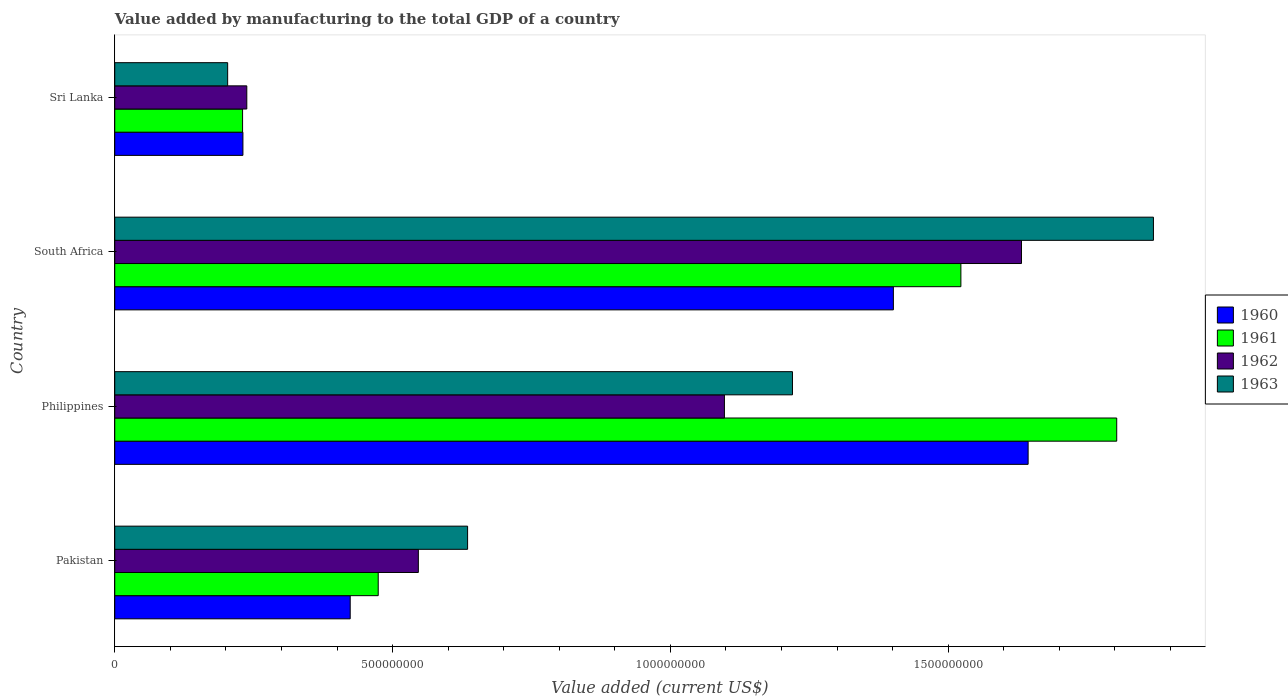How many groups of bars are there?
Your response must be concise. 4. Are the number of bars on each tick of the Y-axis equal?
Make the answer very short. Yes. How many bars are there on the 1st tick from the bottom?
Make the answer very short. 4. What is the label of the 3rd group of bars from the top?
Offer a terse response. Philippines. What is the value added by manufacturing to the total GDP in 1960 in Philippines?
Ensure brevity in your answer.  1.64e+09. Across all countries, what is the maximum value added by manufacturing to the total GDP in 1961?
Your answer should be compact. 1.80e+09. Across all countries, what is the minimum value added by manufacturing to the total GDP in 1963?
Offer a very short reply. 2.03e+08. In which country was the value added by manufacturing to the total GDP in 1963 minimum?
Your answer should be compact. Sri Lanka. What is the total value added by manufacturing to the total GDP in 1963 in the graph?
Your answer should be compact. 3.93e+09. What is the difference between the value added by manufacturing to the total GDP in 1962 in Pakistan and that in Philippines?
Your answer should be very brief. -5.51e+08. What is the difference between the value added by manufacturing to the total GDP in 1963 in South Africa and the value added by manufacturing to the total GDP in 1961 in Pakistan?
Your answer should be compact. 1.40e+09. What is the average value added by manufacturing to the total GDP in 1962 per country?
Your answer should be very brief. 8.78e+08. What is the difference between the value added by manufacturing to the total GDP in 1961 and value added by manufacturing to the total GDP in 1960 in Sri Lanka?
Keep it short and to the point. -6.30e+05. In how many countries, is the value added by manufacturing to the total GDP in 1960 greater than 700000000 US$?
Give a very brief answer. 2. What is the ratio of the value added by manufacturing to the total GDP in 1961 in Pakistan to that in South Africa?
Provide a succinct answer. 0.31. What is the difference between the highest and the second highest value added by manufacturing to the total GDP in 1962?
Keep it short and to the point. 5.35e+08. What is the difference between the highest and the lowest value added by manufacturing to the total GDP in 1963?
Ensure brevity in your answer.  1.67e+09. Is the sum of the value added by manufacturing to the total GDP in 1961 in Philippines and Sri Lanka greater than the maximum value added by manufacturing to the total GDP in 1962 across all countries?
Keep it short and to the point. Yes. Is it the case that in every country, the sum of the value added by manufacturing to the total GDP in 1960 and value added by manufacturing to the total GDP in 1961 is greater than the sum of value added by manufacturing to the total GDP in 1963 and value added by manufacturing to the total GDP in 1962?
Provide a succinct answer. No. What does the 2nd bar from the top in Pakistan represents?
Keep it short and to the point. 1962. What does the 3rd bar from the bottom in Philippines represents?
Provide a succinct answer. 1962. Is it the case that in every country, the sum of the value added by manufacturing to the total GDP in 1961 and value added by manufacturing to the total GDP in 1960 is greater than the value added by manufacturing to the total GDP in 1962?
Ensure brevity in your answer.  Yes. How many countries are there in the graph?
Provide a succinct answer. 4. Are the values on the major ticks of X-axis written in scientific E-notation?
Provide a short and direct response. No. Does the graph contain any zero values?
Ensure brevity in your answer.  No. Where does the legend appear in the graph?
Ensure brevity in your answer.  Center right. How many legend labels are there?
Provide a succinct answer. 4. How are the legend labels stacked?
Give a very brief answer. Vertical. What is the title of the graph?
Ensure brevity in your answer.  Value added by manufacturing to the total GDP of a country. What is the label or title of the X-axis?
Your answer should be compact. Value added (current US$). What is the Value added (current US$) in 1960 in Pakistan?
Offer a terse response. 4.24e+08. What is the Value added (current US$) in 1961 in Pakistan?
Your answer should be compact. 4.74e+08. What is the Value added (current US$) in 1962 in Pakistan?
Your answer should be compact. 5.46e+08. What is the Value added (current US$) of 1963 in Pakistan?
Your answer should be very brief. 6.35e+08. What is the Value added (current US$) in 1960 in Philippines?
Provide a succinct answer. 1.64e+09. What is the Value added (current US$) of 1961 in Philippines?
Give a very brief answer. 1.80e+09. What is the Value added (current US$) in 1962 in Philippines?
Ensure brevity in your answer.  1.10e+09. What is the Value added (current US$) in 1963 in Philippines?
Offer a very short reply. 1.22e+09. What is the Value added (current US$) in 1960 in South Africa?
Offer a very short reply. 1.40e+09. What is the Value added (current US$) of 1961 in South Africa?
Offer a terse response. 1.52e+09. What is the Value added (current US$) in 1962 in South Africa?
Ensure brevity in your answer.  1.63e+09. What is the Value added (current US$) of 1963 in South Africa?
Provide a succinct answer. 1.87e+09. What is the Value added (current US$) of 1960 in Sri Lanka?
Make the answer very short. 2.31e+08. What is the Value added (current US$) of 1961 in Sri Lanka?
Your answer should be very brief. 2.30e+08. What is the Value added (current US$) of 1962 in Sri Lanka?
Your answer should be compact. 2.38e+08. What is the Value added (current US$) of 1963 in Sri Lanka?
Make the answer very short. 2.03e+08. Across all countries, what is the maximum Value added (current US$) of 1960?
Your answer should be compact. 1.64e+09. Across all countries, what is the maximum Value added (current US$) in 1961?
Give a very brief answer. 1.80e+09. Across all countries, what is the maximum Value added (current US$) in 1962?
Your answer should be compact. 1.63e+09. Across all countries, what is the maximum Value added (current US$) in 1963?
Provide a short and direct response. 1.87e+09. Across all countries, what is the minimum Value added (current US$) in 1960?
Provide a succinct answer. 2.31e+08. Across all countries, what is the minimum Value added (current US$) in 1961?
Your answer should be compact. 2.30e+08. Across all countries, what is the minimum Value added (current US$) of 1962?
Your response must be concise. 2.38e+08. Across all countries, what is the minimum Value added (current US$) of 1963?
Provide a short and direct response. 2.03e+08. What is the total Value added (current US$) of 1960 in the graph?
Offer a terse response. 3.70e+09. What is the total Value added (current US$) of 1961 in the graph?
Keep it short and to the point. 4.03e+09. What is the total Value added (current US$) of 1962 in the graph?
Offer a terse response. 3.51e+09. What is the total Value added (current US$) in 1963 in the graph?
Offer a terse response. 3.93e+09. What is the difference between the Value added (current US$) of 1960 in Pakistan and that in Philippines?
Your answer should be very brief. -1.22e+09. What is the difference between the Value added (current US$) of 1961 in Pakistan and that in Philippines?
Your answer should be very brief. -1.33e+09. What is the difference between the Value added (current US$) of 1962 in Pakistan and that in Philippines?
Your response must be concise. -5.51e+08. What is the difference between the Value added (current US$) in 1963 in Pakistan and that in Philippines?
Your answer should be very brief. -5.85e+08. What is the difference between the Value added (current US$) in 1960 in Pakistan and that in South Africa?
Ensure brevity in your answer.  -9.78e+08. What is the difference between the Value added (current US$) of 1961 in Pakistan and that in South Africa?
Offer a very short reply. -1.05e+09. What is the difference between the Value added (current US$) of 1962 in Pakistan and that in South Africa?
Provide a succinct answer. -1.09e+09. What is the difference between the Value added (current US$) of 1963 in Pakistan and that in South Africa?
Ensure brevity in your answer.  -1.23e+09. What is the difference between the Value added (current US$) in 1960 in Pakistan and that in Sri Lanka?
Make the answer very short. 1.93e+08. What is the difference between the Value added (current US$) of 1961 in Pakistan and that in Sri Lanka?
Make the answer very short. 2.44e+08. What is the difference between the Value added (current US$) of 1962 in Pakistan and that in Sri Lanka?
Your answer should be compact. 3.09e+08. What is the difference between the Value added (current US$) of 1963 in Pakistan and that in Sri Lanka?
Give a very brief answer. 4.32e+08. What is the difference between the Value added (current US$) of 1960 in Philippines and that in South Africa?
Your answer should be very brief. 2.43e+08. What is the difference between the Value added (current US$) of 1961 in Philippines and that in South Africa?
Provide a short and direct response. 2.80e+08. What is the difference between the Value added (current US$) in 1962 in Philippines and that in South Africa?
Your answer should be compact. -5.35e+08. What is the difference between the Value added (current US$) in 1963 in Philippines and that in South Africa?
Your response must be concise. -6.50e+08. What is the difference between the Value added (current US$) in 1960 in Philippines and that in Sri Lanka?
Your answer should be very brief. 1.41e+09. What is the difference between the Value added (current US$) of 1961 in Philippines and that in Sri Lanka?
Make the answer very short. 1.57e+09. What is the difference between the Value added (current US$) in 1962 in Philippines and that in Sri Lanka?
Provide a short and direct response. 8.60e+08. What is the difference between the Value added (current US$) in 1963 in Philippines and that in Sri Lanka?
Your response must be concise. 1.02e+09. What is the difference between the Value added (current US$) of 1960 in South Africa and that in Sri Lanka?
Provide a succinct answer. 1.17e+09. What is the difference between the Value added (current US$) of 1961 in South Africa and that in Sri Lanka?
Provide a succinct answer. 1.29e+09. What is the difference between the Value added (current US$) of 1962 in South Africa and that in Sri Lanka?
Keep it short and to the point. 1.39e+09. What is the difference between the Value added (current US$) in 1963 in South Africa and that in Sri Lanka?
Give a very brief answer. 1.67e+09. What is the difference between the Value added (current US$) of 1960 in Pakistan and the Value added (current US$) of 1961 in Philippines?
Give a very brief answer. -1.38e+09. What is the difference between the Value added (current US$) of 1960 in Pakistan and the Value added (current US$) of 1962 in Philippines?
Offer a terse response. -6.74e+08. What is the difference between the Value added (current US$) of 1960 in Pakistan and the Value added (current US$) of 1963 in Philippines?
Your response must be concise. -7.96e+08. What is the difference between the Value added (current US$) in 1961 in Pakistan and the Value added (current US$) in 1962 in Philippines?
Ensure brevity in your answer.  -6.23e+08. What is the difference between the Value added (current US$) in 1961 in Pakistan and the Value added (current US$) in 1963 in Philippines?
Your response must be concise. -7.46e+08. What is the difference between the Value added (current US$) in 1962 in Pakistan and the Value added (current US$) in 1963 in Philippines?
Your response must be concise. -6.73e+08. What is the difference between the Value added (current US$) of 1960 in Pakistan and the Value added (current US$) of 1961 in South Africa?
Provide a succinct answer. -1.10e+09. What is the difference between the Value added (current US$) of 1960 in Pakistan and the Value added (current US$) of 1962 in South Africa?
Ensure brevity in your answer.  -1.21e+09. What is the difference between the Value added (current US$) of 1960 in Pakistan and the Value added (current US$) of 1963 in South Africa?
Your answer should be very brief. -1.45e+09. What is the difference between the Value added (current US$) of 1961 in Pakistan and the Value added (current US$) of 1962 in South Africa?
Offer a very short reply. -1.16e+09. What is the difference between the Value added (current US$) of 1961 in Pakistan and the Value added (current US$) of 1963 in South Africa?
Ensure brevity in your answer.  -1.40e+09. What is the difference between the Value added (current US$) of 1962 in Pakistan and the Value added (current US$) of 1963 in South Africa?
Your answer should be compact. -1.32e+09. What is the difference between the Value added (current US$) in 1960 in Pakistan and the Value added (current US$) in 1961 in Sri Lanka?
Offer a very short reply. 1.94e+08. What is the difference between the Value added (current US$) in 1960 in Pakistan and the Value added (current US$) in 1962 in Sri Lanka?
Offer a very short reply. 1.86e+08. What is the difference between the Value added (current US$) in 1960 in Pakistan and the Value added (current US$) in 1963 in Sri Lanka?
Ensure brevity in your answer.  2.21e+08. What is the difference between the Value added (current US$) of 1961 in Pakistan and the Value added (current US$) of 1962 in Sri Lanka?
Give a very brief answer. 2.37e+08. What is the difference between the Value added (current US$) of 1961 in Pakistan and the Value added (current US$) of 1963 in Sri Lanka?
Offer a very short reply. 2.71e+08. What is the difference between the Value added (current US$) in 1962 in Pakistan and the Value added (current US$) in 1963 in Sri Lanka?
Provide a succinct answer. 3.43e+08. What is the difference between the Value added (current US$) of 1960 in Philippines and the Value added (current US$) of 1961 in South Africa?
Give a very brief answer. 1.21e+08. What is the difference between the Value added (current US$) in 1960 in Philippines and the Value added (current US$) in 1962 in South Africa?
Offer a very short reply. 1.19e+07. What is the difference between the Value added (current US$) in 1960 in Philippines and the Value added (current US$) in 1963 in South Africa?
Give a very brief answer. -2.26e+08. What is the difference between the Value added (current US$) of 1961 in Philippines and the Value added (current US$) of 1962 in South Africa?
Provide a short and direct response. 1.71e+08. What is the difference between the Value added (current US$) in 1961 in Philippines and the Value added (current US$) in 1963 in South Africa?
Your answer should be compact. -6.61e+07. What is the difference between the Value added (current US$) in 1962 in Philippines and the Value added (current US$) in 1963 in South Africa?
Your response must be concise. -7.72e+08. What is the difference between the Value added (current US$) of 1960 in Philippines and the Value added (current US$) of 1961 in Sri Lanka?
Your answer should be very brief. 1.41e+09. What is the difference between the Value added (current US$) in 1960 in Philippines and the Value added (current US$) in 1962 in Sri Lanka?
Give a very brief answer. 1.41e+09. What is the difference between the Value added (current US$) in 1960 in Philippines and the Value added (current US$) in 1963 in Sri Lanka?
Ensure brevity in your answer.  1.44e+09. What is the difference between the Value added (current US$) in 1961 in Philippines and the Value added (current US$) in 1962 in Sri Lanka?
Your answer should be very brief. 1.57e+09. What is the difference between the Value added (current US$) of 1961 in Philippines and the Value added (current US$) of 1963 in Sri Lanka?
Your answer should be compact. 1.60e+09. What is the difference between the Value added (current US$) in 1962 in Philippines and the Value added (current US$) in 1963 in Sri Lanka?
Offer a terse response. 8.94e+08. What is the difference between the Value added (current US$) in 1960 in South Africa and the Value added (current US$) in 1961 in Sri Lanka?
Give a very brief answer. 1.17e+09. What is the difference between the Value added (current US$) of 1960 in South Africa and the Value added (current US$) of 1962 in Sri Lanka?
Your response must be concise. 1.16e+09. What is the difference between the Value added (current US$) of 1960 in South Africa and the Value added (current US$) of 1963 in Sri Lanka?
Offer a very short reply. 1.20e+09. What is the difference between the Value added (current US$) of 1961 in South Africa and the Value added (current US$) of 1962 in Sri Lanka?
Make the answer very short. 1.29e+09. What is the difference between the Value added (current US$) in 1961 in South Africa and the Value added (current US$) in 1963 in Sri Lanka?
Offer a very short reply. 1.32e+09. What is the difference between the Value added (current US$) in 1962 in South Africa and the Value added (current US$) in 1963 in Sri Lanka?
Ensure brevity in your answer.  1.43e+09. What is the average Value added (current US$) in 1960 per country?
Your answer should be very brief. 9.25e+08. What is the average Value added (current US$) in 1961 per country?
Your answer should be very brief. 1.01e+09. What is the average Value added (current US$) in 1962 per country?
Give a very brief answer. 8.78e+08. What is the average Value added (current US$) in 1963 per country?
Ensure brevity in your answer.  9.82e+08. What is the difference between the Value added (current US$) in 1960 and Value added (current US$) in 1961 in Pakistan?
Offer a very short reply. -5.04e+07. What is the difference between the Value added (current US$) of 1960 and Value added (current US$) of 1962 in Pakistan?
Provide a short and direct response. -1.23e+08. What is the difference between the Value added (current US$) in 1960 and Value added (current US$) in 1963 in Pakistan?
Your answer should be very brief. -2.11e+08. What is the difference between the Value added (current US$) in 1961 and Value added (current US$) in 1962 in Pakistan?
Make the answer very short. -7.22e+07. What is the difference between the Value added (current US$) of 1961 and Value added (current US$) of 1963 in Pakistan?
Give a very brief answer. -1.61e+08. What is the difference between the Value added (current US$) of 1962 and Value added (current US$) of 1963 in Pakistan?
Keep it short and to the point. -8.86e+07. What is the difference between the Value added (current US$) in 1960 and Value added (current US$) in 1961 in Philippines?
Offer a terse response. -1.59e+08. What is the difference between the Value added (current US$) in 1960 and Value added (current US$) in 1962 in Philippines?
Your answer should be compact. 5.47e+08. What is the difference between the Value added (current US$) in 1960 and Value added (current US$) in 1963 in Philippines?
Keep it short and to the point. 4.24e+08. What is the difference between the Value added (current US$) in 1961 and Value added (current US$) in 1962 in Philippines?
Ensure brevity in your answer.  7.06e+08. What is the difference between the Value added (current US$) of 1961 and Value added (current US$) of 1963 in Philippines?
Give a very brief answer. 5.84e+08. What is the difference between the Value added (current US$) in 1962 and Value added (current US$) in 1963 in Philippines?
Ensure brevity in your answer.  -1.22e+08. What is the difference between the Value added (current US$) of 1960 and Value added (current US$) of 1961 in South Africa?
Provide a succinct answer. -1.21e+08. What is the difference between the Value added (current US$) in 1960 and Value added (current US$) in 1962 in South Africa?
Provide a succinct answer. -2.31e+08. What is the difference between the Value added (current US$) of 1960 and Value added (current US$) of 1963 in South Africa?
Offer a very short reply. -4.68e+08. What is the difference between the Value added (current US$) in 1961 and Value added (current US$) in 1962 in South Africa?
Your response must be concise. -1.09e+08. What is the difference between the Value added (current US$) of 1961 and Value added (current US$) of 1963 in South Africa?
Offer a very short reply. -3.47e+08. What is the difference between the Value added (current US$) of 1962 and Value added (current US$) of 1963 in South Africa?
Your response must be concise. -2.37e+08. What is the difference between the Value added (current US$) in 1960 and Value added (current US$) in 1961 in Sri Lanka?
Your response must be concise. 6.30e+05. What is the difference between the Value added (current US$) of 1960 and Value added (current US$) of 1962 in Sri Lanka?
Provide a succinct answer. -6.98e+06. What is the difference between the Value added (current US$) in 1960 and Value added (current US$) in 1963 in Sri Lanka?
Your response must be concise. 2.75e+07. What is the difference between the Value added (current US$) in 1961 and Value added (current US$) in 1962 in Sri Lanka?
Make the answer very short. -7.61e+06. What is the difference between the Value added (current US$) in 1961 and Value added (current US$) in 1963 in Sri Lanka?
Give a very brief answer. 2.68e+07. What is the difference between the Value added (current US$) in 1962 and Value added (current US$) in 1963 in Sri Lanka?
Offer a very short reply. 3.45e+07. What is the ratio of the Value added (current US$) in 1960 in Pakistan to that in Philippines?
Provide a short and direct response. 0.26. What is the ratio of the Value added (current US$) of 1961 in Pakistan to that in Philippines?
Make the answer very short. 0.26. What is the ratio of the Value added (current US$) of 1962 in Pakistan to that in Philippines?
Your answer should be very brief. 0.5. What is the ratio of the Value added (current US$) of 1963 in Pakistan to that in Philippines?
Keep it short and to the point. 0.52. What is the ratio of the Value added (current US$) in 1960 in Pakistan to that in South Africa?
Keep it short and to the point. 0.3. What is the ratio of the Value added (current US$) in 1961 in Pakistan to that in South Africa?
Make the answer very short. 0.31. What is the ratio of the Value added (current US$) of 1962 in Pakistan to that in South Africa?
Offer a very short reply. 0.33. What is the ratio of the Value added (current US$) in 1963 in Pakistan to that in South Africa?
Provide a short and direct response. 0.34. What is the ratio of the Value added (current US$) in 1960 in Pakistan to that in Sri Lanka?
Your response must be concise. 1.84. What is the ratio of the Value added (current US$) in 1961 in Pakistan to that in Sri Lanka?
Keep it short and to the point. 2.06. What is the ratio of the Value added (current US$) in 1962 in Pakistan to that in Sri Lanka?
Your answer should be compact. 2.3. What is the ratio of the Value added (current US$) in 1963 in Pakistan to that in Sri Lanka?
Give a very brief answer. 3.13. What is the ratio of the Value added (current US$) in 1960 in Philippines to that in South Africa?
Provide a short and direct response. 1.17. What is the ratio of the Value added (current US$) of 1961 in Philippines to that in South Africa?
Your response must be concise. 1.18. What is the ratio of the Value added (current US$) in 1962 in Philippines to that in South Africa?
Keep it short and to the point. 0.67. What is the ratio of the Value added (current US$) of 1963 in Philippines to that in South Africa?
Offer a terse response. 0.65. What is the ratio of the Value added (current US$) of 1960 in Philippines to that in Sri Lanka?
Provide a succinct answer. 7.13. What is the ratio of the Value added (current US$) of 1961 in Philippines to that in Sri Lanka?
Your answer should be very brief. 7.84. What is the ratio of the Value added (current US$) of 1962 in Philippines to that in Sri Lanka?
Your answer should be compact. 4.62. What is the ratio of the Value added (current US$) in 1963 in Philippines to that in Sri Lanka?
Your answer should be compact. 6. What is the ratio of the Value added (current US$) in 1960 in South Africa to that in Sri Lanka?
Provide a succinct answer. 6.08. What is the ratio of the Value added (current US$) in 1961 in South Africa to that in Sri Lanka?
Provide a succinct answer. 6.62. What is the ratio of the Value added (current US$) in 1962 in South Africa to that in Sri Lanka?
Keep it short and to the point. 6.87. What is the ratio of the Value added (current US$) of 1963 in South Africa to that in Sri Lanka?
Your answer should be compact. 9.2. What is the difference between the highest and the second highest Value added (current US$) in 1960?
Your answer should be very brief. 2.43e+08. What is the difference between the highest and the second highest Value added (current US$) in 1961?
Your answer should be very brief. 2.80e+08. What is the difference between the highest and the second highest Value added (current US$) in 1962?
Your answer should be compact. 5.35e+08. What is the difference between the highest and the second highest Value added (current US$) in 1963?
Provide a short and direct response. 6.50e+08. What is the difference between the highest and the lowest Value added (current US$) of 1960?
Offer a very short reply. 1.41e+09. What is the difference between the highest and the lowest Value added (current US$) of 1961?
Your response must be concise. 1.57e+09. What is the difference between the highest and the lowest Value added (current US$) of 1962?
Keep it short and to the point. 1.39e+09. What is the difference between the highest and the lowest Value added (current US$) in 1963?
Provide a succinct answer. 1.67e+09. 